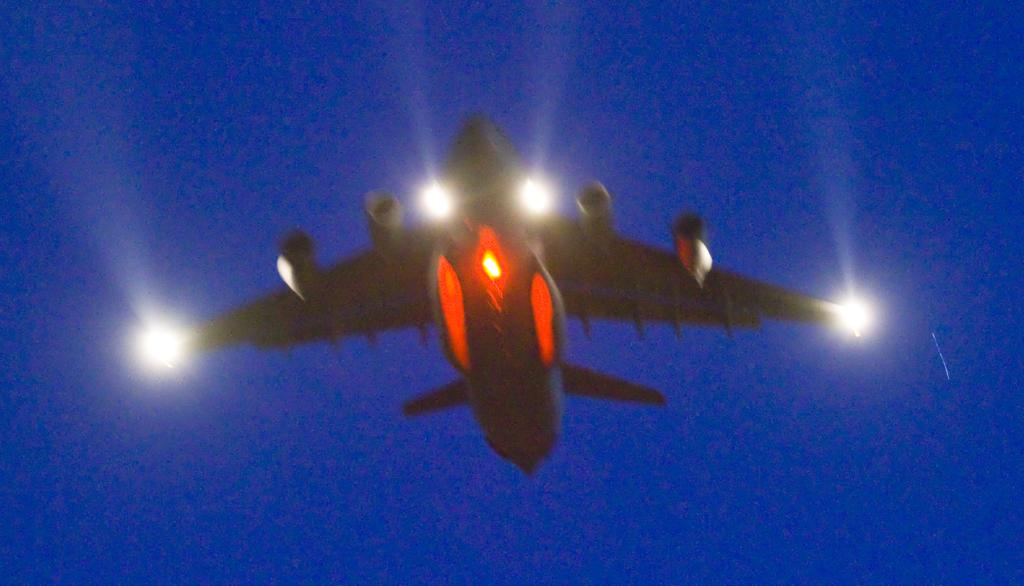What is the main subject of the image? The main subject of the image is an airplane. What color is the background of the image? The background of the image is blue. Can you see a duck showcasing a rose in the image? There is no duck or rose present in the image, and therefore no such event can be observed. 